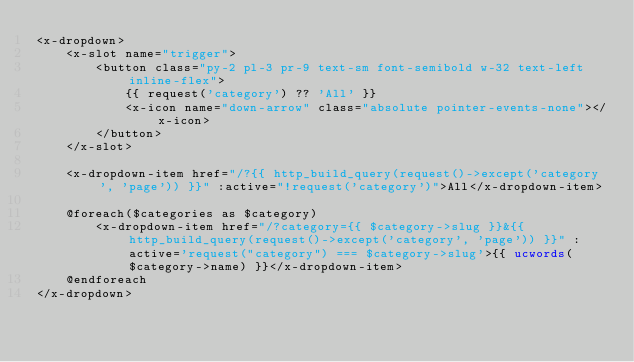<code> <loc_0><loc_0><loc_500><loc_500><_PHP_><x-dropdown>
    <x-slot name="trigger">
        <button class="py-2 pl-3 pr-9 text-sm font-semibold w-32 text-left inline-flex">
            {{ request('category') ?? 'All' }}
            <x-icon name="down-arrow" class="absolute pointer-events-none"></x-icon>
        </button>
    </x-slot>

    <x-dropdown-item href="/?{{ http_build_query(request()->except('category', 'page')) }}" :active="!request('category')">All</x-dropdown-item>

    @foreach($categories as $category)
        <x-dropdown-item href="/?category={{ $category->slug }}&{{ http_build_query(request()->except('category', 'page')) }}" :active='request("category") === $category->slug'>{{ ucwords($category->name) }}</x-dropdown-item>
    @endforeach
</x-dropdown>
</code> 